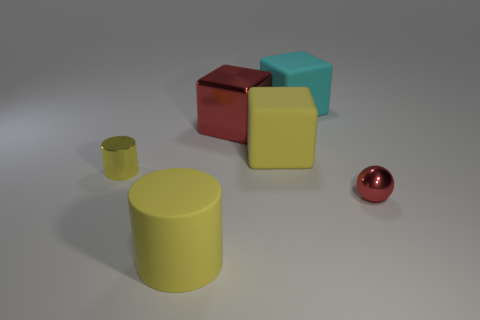Subtract all big rubber cubes. How many cubes are left? 1 Add 1 tiny cyan metallic objects. How many objects exist? 7 Subtract all red blocks. How many blocks are left? 2 Subtract 0 gray cylinders. How many objects are left? 6 Subtract all cylinders. How many objects are left? 4 Subtract all green balls. Subtract all red cubes. How many balls are left? 1 Subtract all cyan matte cylinders. Subtract all shiny blocks. How many objects are left? 5 Add 1 small yellow shiny cylinders. How many small yellow shiny cylinders are left? 2 Add 5 big blue cylinders. How many big blue cylinders exist? 5 